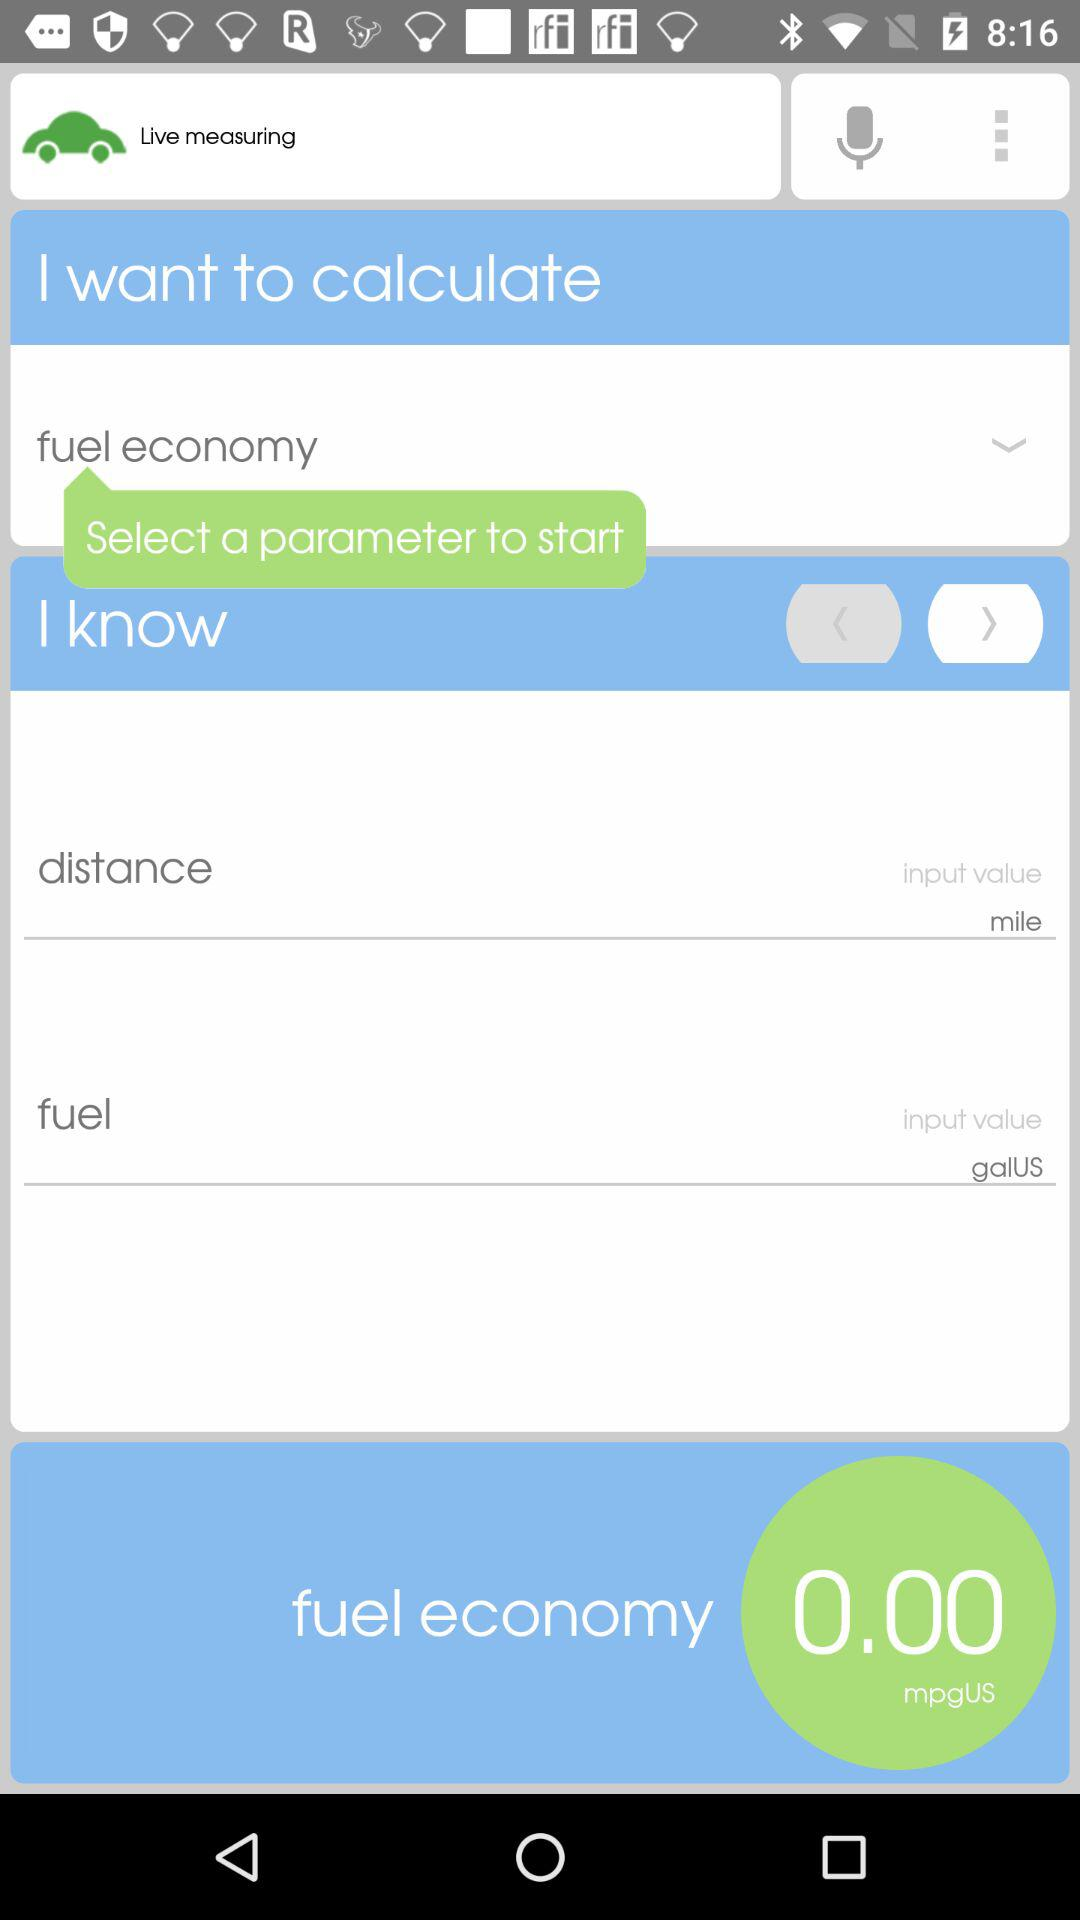What is the application name?
When the provided information is insufficient, respond with <no answer>. <no answer> 